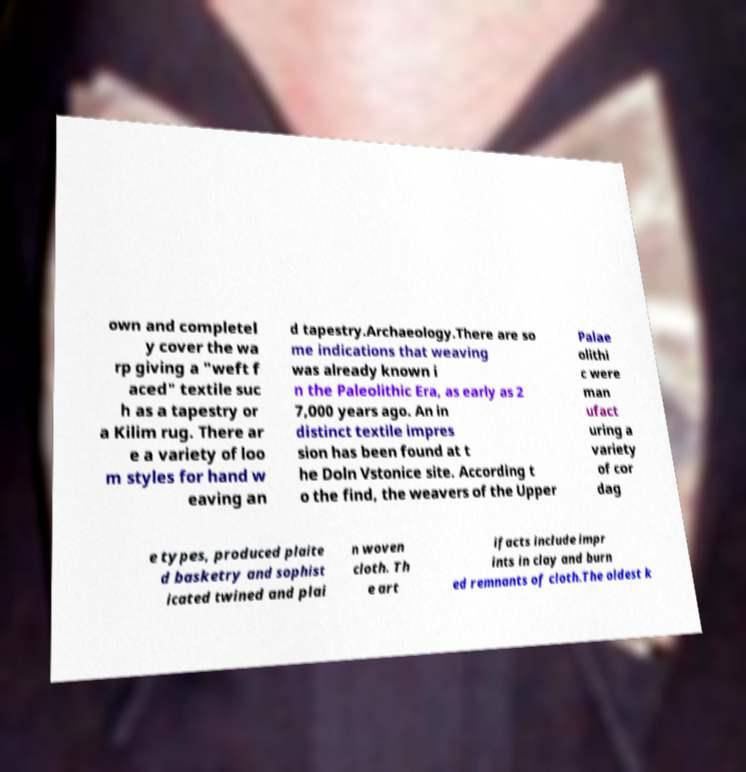Could you assist in decoding the text presented in this image and type it out clearly? own and completel y cover the wa rp giving a "weft f aced" textile suc h as a tapestry or a Kilim rug. There ar e a variety of loo m styles for hand w eaving an d tapestry.Archaeology.There are so me indications that weaving was already known i n the Paleolithic Era, as early as 2 7,000 years ago. An in distinct textile impres sion has been found at t he Doln Vstonice site. According t o the find, the weavers of the Upper Palae olithi c were man ufact uring a variety of cor dag e types, produced plaite d basketry and sophist icated twined and plai n woven cloth. Th e art ifacts include impr ints in clay and burn ed remnants of cloth.The oldest k 